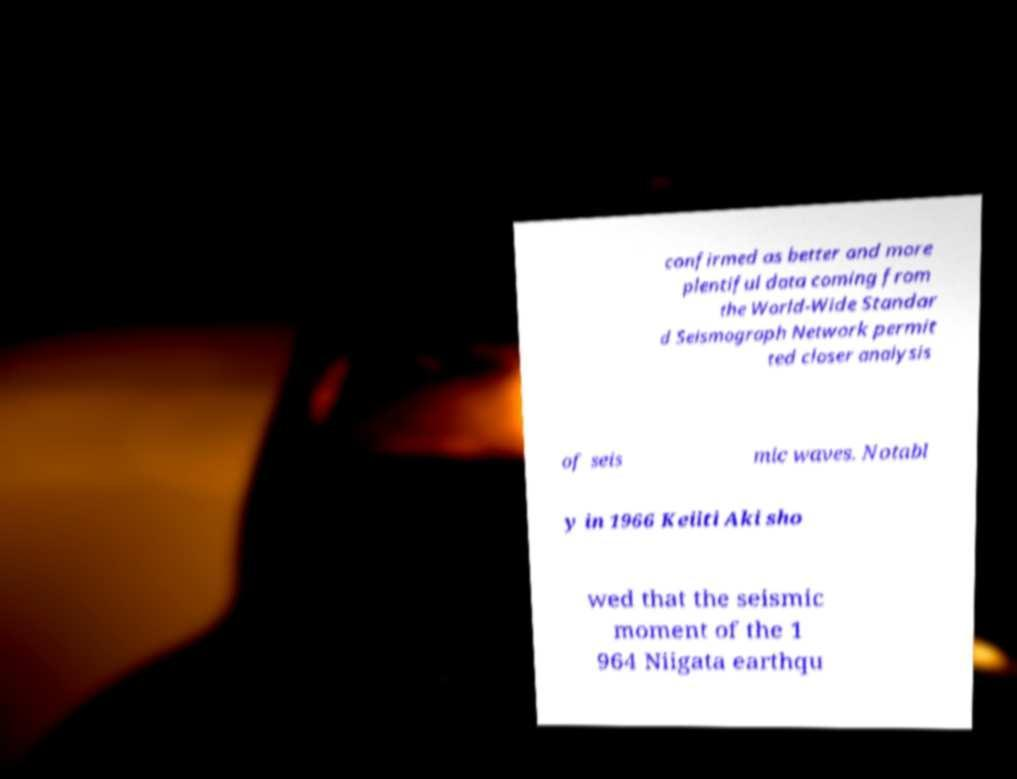I need the written content from this picture converted into text. Can you do that? confirmed as better and more plentiful data coming from the World-Wide Standar d Seismograph Network permit ted closer analysis of seis mic waves. Notabl y in 1966 Keiiti Aki sho wed that the seismic moment of the 1 964 Niigata earthqu 